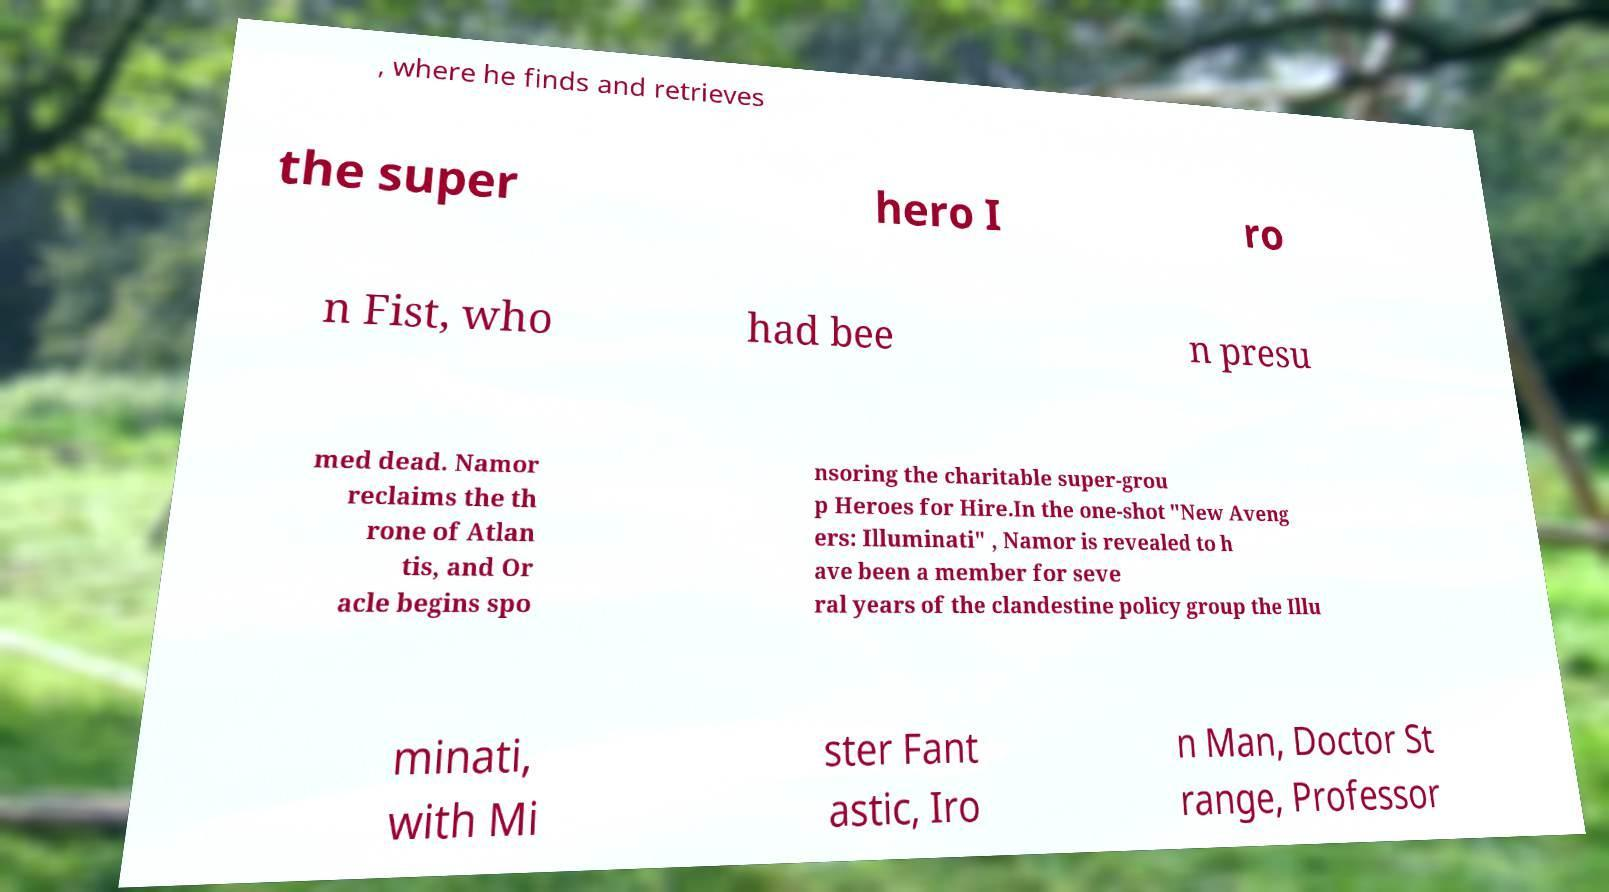Could you assist in decoding the text presented in this image and type it out clearly? , where he finds and retrieves the super hero I ro n Fist, who had bee n presu med dead. Namor reclaims the th rone of Atlan tis, and Or acle begins spo nsoring the charitable super-grou p Heroes for Hire.In the one-shot "New Aveng ers: Illuminati" , Namor is revealed to h ave been a member for seve ral years of the clandestine policy group the Illu minati, with Mi ster Fant astic, Iro n Man, Doctor St range, Professor 